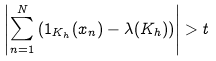Convert formula to latex. <formula><loc_0><loc_0><loc_500><loc_500>\left | \sum _ { n = 1 } ^ { N } \left ( 1 _ { K _ { h } } ( x _ { n } ) - \lambda ( K _ { h } ) \right ) \right | > t</formula> 